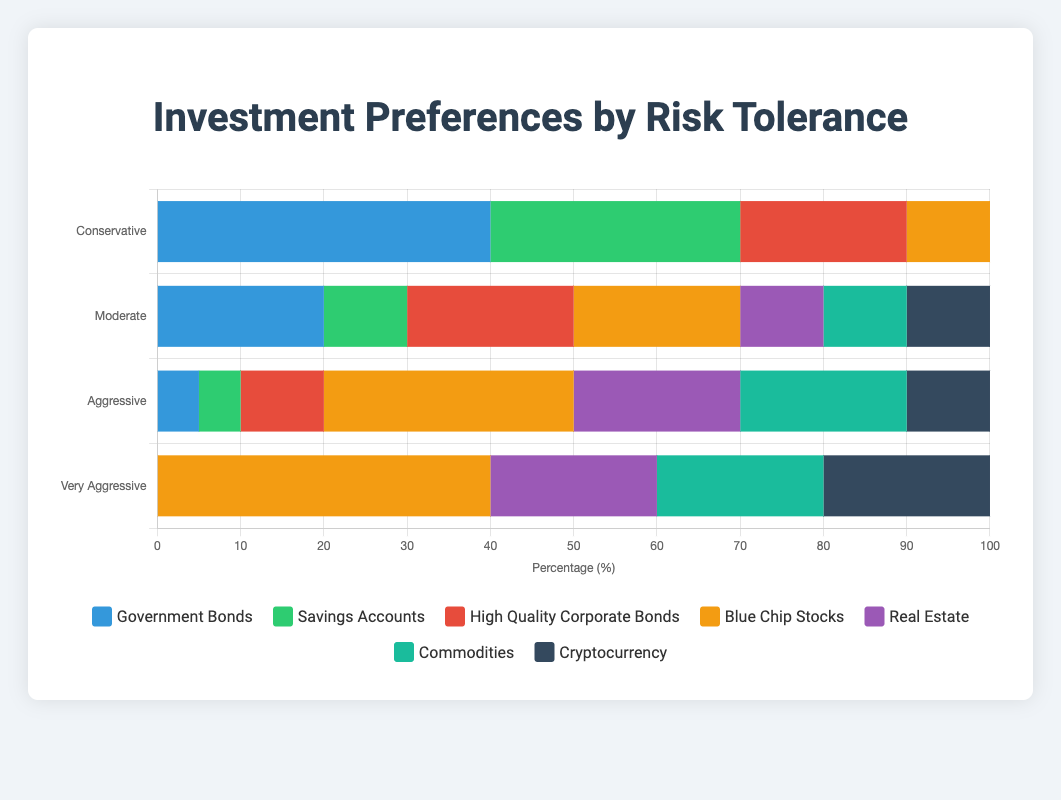**Question 1:**
Which investment type has the highest allocation for the "Very Aggressive" risk tolerance group? Start by looking at the "Very Aggressive" row in the chart. The investment type with the longest bar (or largest percentage) is "Blue Chip Stocks" at 40%.
Answer: Blue Chip Stocks **Question 2:** 
Compare the percentage of investments in "Government Bonds" between the "Conservative" and "Moderate" risk tolerance levels. In the "Conservative" group, "Government Bonds" make up 40%. For the "Moderate" group, the percentage is 20%. Comparing these values, "Conservative" has a higher allocation.
Answer: Conservative **Question 3:**
How much more investment in "Savings Accounts" is there in the "Conservative" group compared to the "Moderate" group? For "Conservative," "Savings Accounts" are 30%. For "Moderate," it is 10%. The difference can be calculated as 30% - 10% = 20%.
Answer: 20% **Question 4:**
Which risk tolerance level has an equal percentage of investments in three different asset classes, and what are those percentages? Find the row where three percentages are the same. For "Moderate," "High Quality Corporate Bonds," "Blue Chip Stocks," and "Cryptocurrency" are all at 20%.
Answer: Moderate, 20% **Question 5:**
What is the total percentage of investments in speculative assets (Commodities and Cryptocurrency) for the "Very Aggressive" group? Look at the "Very Aggressive" risk level for "Commodities" and "Cryptocurrency." Both are 20%. Add them up: 20% + 20% = 40%.
Answer: 40% **Question 6:**
Compare the percentage allocations to "Blue Chip Stocks" between the "Aggressive" and "Very Aggressive" risk tolerance levels. Explain which level has more and by how much. The "Aggressive" group has 30% allocation to "Blue Chip Stocks", while the "Very Aggressive" group has 40%. The difference is 40% - 30% = 10%. The "Very Aggressive" level has 10% more allocated to "Blue Chip Stocks."
Answer: Very Aggressive, 10% **Question 7:**
What is the combined percentage of investments in "Government Bonds" and "Blue Chip Stocks" for the "Aggressive" group? For "Aggressive," "Government Bonds" are 5% and "Blue Chip Stocks" are 30%. Adding these together: 5% + 30% = 35%.
Answer: 35% **Question 8:**
Which investment types have zero allocation in the "Conservative" risk tolerance group? By looking at the chart for the "Conservative" group, "Real Estate," "Commodities," and "Cryptocurrency" all have 0% allocation.
Answer: Real Estate, Commodities, Cryptocurrency 